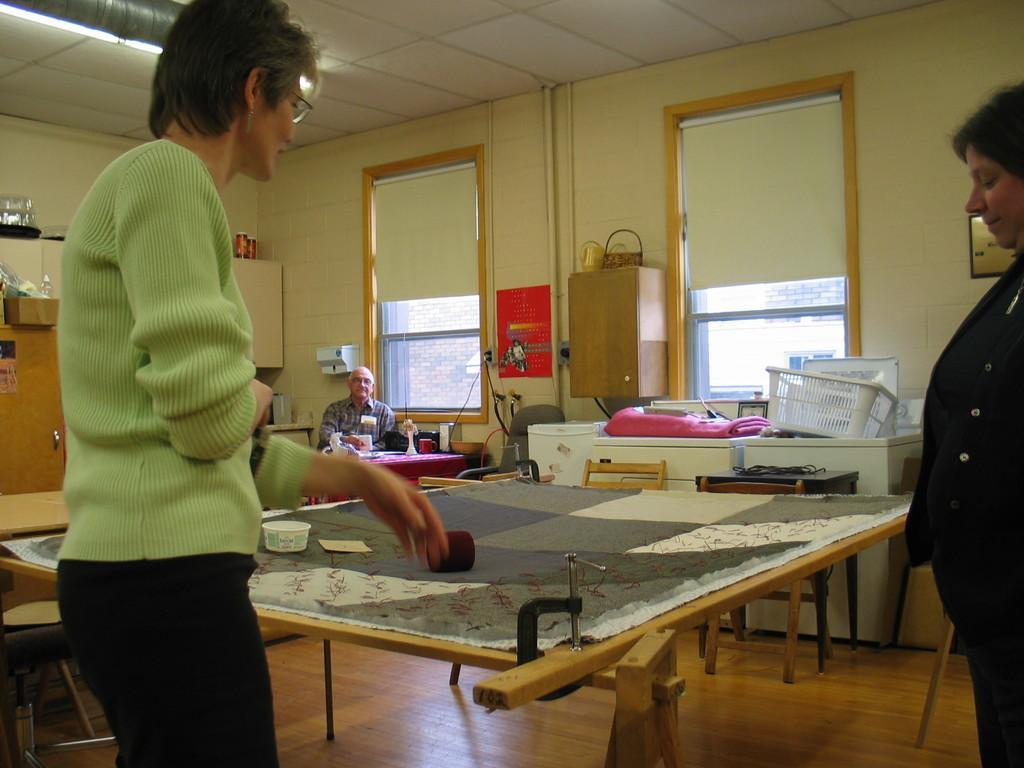Can you describe this image briefly? This picture is consists of a room where there are two ladies they are standing at the right and left side of the image and there are windows at the center of the image and there is a person who is sitting on the chair at the left side of the image. 